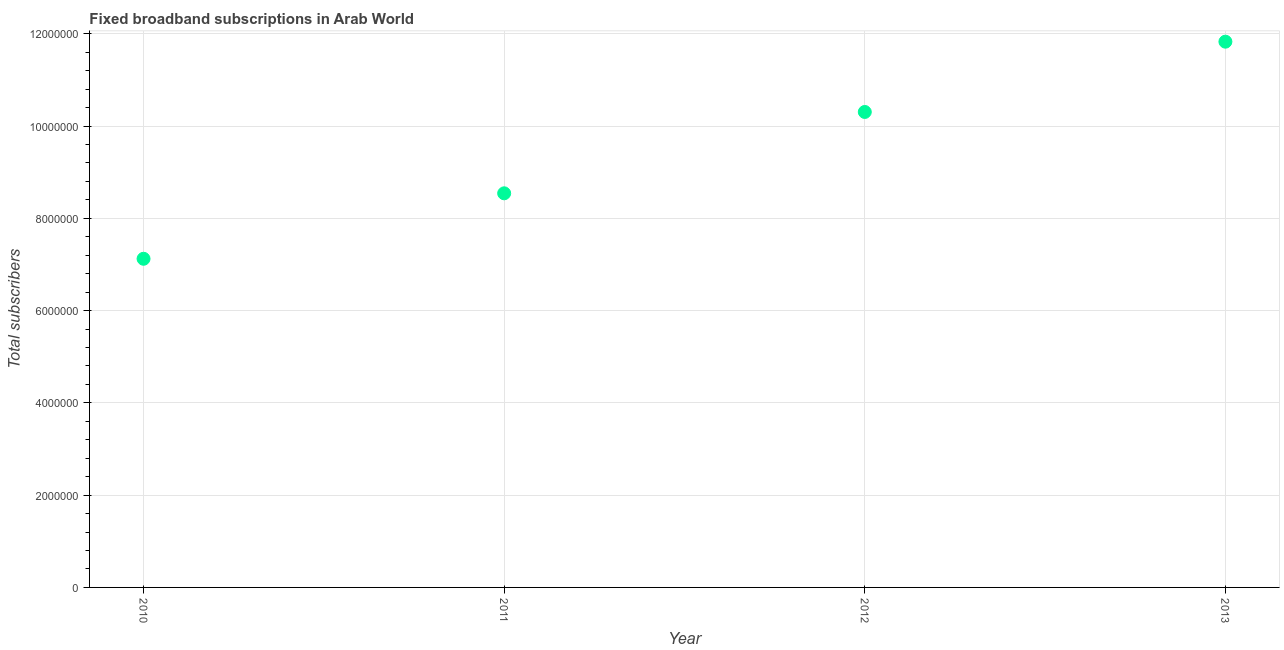What is the total number of fixed broadband subscriptions in 2011?
Your answer should be compact. 8.54e+06. Across all years, what is the maximum total number of fixed broadband subscriptions?
Give a very brief answer. 1.18e+07. Across all years, what is the minimum total number of fixed broadband subscriptions?
Keep it short and to the point. 7.12e+06. What is the sum of the total number of fixed broadband subscriptions?
Provide a succinct answer. 3.78e+07. What is the difference between the total number of fixed broadband subscriptions in 2011 and 2013?
Keep it short and to the point. -3.29e+06. What is the average total number of fixed broadband subscriptions per year?
Make the answer very short. 9.45e+06. What is the median total number of fixed broadband subscriptions?
Your response must be concise. 9.42e+06. In how many years, is the total number of fixed broadband subscriptions greater than 8800000 ?
Give a very brief answer. 2. Do a majority of the years between 2011 and 2010 (inclusive) have total number of fixed broadband subscriptions greater than 7600000 ?
Your answer should be compact. No. What is the ratio of the total number of fixed broadband subscriptions in 2012 to that in 2013?
Your answer should be compact. 0.87. Is the total number of fixed broadband subscriptions in 2010 less than that in 2012?
Ensure brevity in your answer.  Yes. What is the difference between the highest and the second highest total number of fixed broadband subscriptions?
Your answer should be compact. 1.52e+06. What is the difference between the highest and the lowest total number of fixed broadband subscriptions?
Make the answer very short. 4.71e+06. Does the total number of fixed broadband subscriptions monotonically increase over the years?
Your answer should be compact. Yes. How many dotlines are there?
Provide a short and direct response. 1. What is the difference between two consecutive major ticks on the Y-axis?
Your answer should be compact. 2.00e+06. Does the graph contain any zero values?
Provide a short and direct response. No. What is the title of the graph?
Offer a very short reply. Fixed broadband subscriptions in Arab World. What is the label or title of the Y-axis?
Your answer should be compact. Total subscribers. What is the Total subscribers in 2010?
Your response must be concise. 7.12e+06. What is the Total subscribers in 2011?
Keep it short and to the point. 8.54e+06. What is the Total subscribers in 2012?
Make the answer very short. 1.03e+07. What is the Total subscribers in 2013?
Your response must be concise. 1.18e+07. What is the difference between the Total subscribers in 2010 and 2011?
Offer a terse response. -1.42e+06. What is the difference between the Total subscribers in 2010 and 2012?
Your answer should be very brief. -3.18e+06. What is the difference between the Total subscribers in 2010 and 2013?
Offer a very short reply. -4.71e+06. What is the difference between the Total subscribers in 2011 and 2012?
Keep it short and to the point. -1.76e+06. What is the difference between the Total subscribers in 2011 and 2013?
Keep it short and to the point. -3.29e+06. What is the difference between the Total subscribers in 2012 and 2013?
Keep it short and to the point. -1.52e+06. What is the ratio of the Total subscribers in 2010 to that in 2011?
Make the answer very short. 0.83. What is the ratio of the Total subscribers in 2010 to that in 2012?
Your answer should be very brief. 0.69. What is the ratio of the Total subscribers in 2010 to that in 2013?
Give a very brief answer. 0.6. What is the ratio of the Total subscribers in 2011 to that in 2012?
Provide a succinct answer. 0.83. What is the ratio of the Total subscribers in 2011 to that in 2013?
Your answer should be compact. 0.72. What is the ratio of the Total subscribers in 2012 to that in 2013?
Keep it short and to the point. 0.87. 